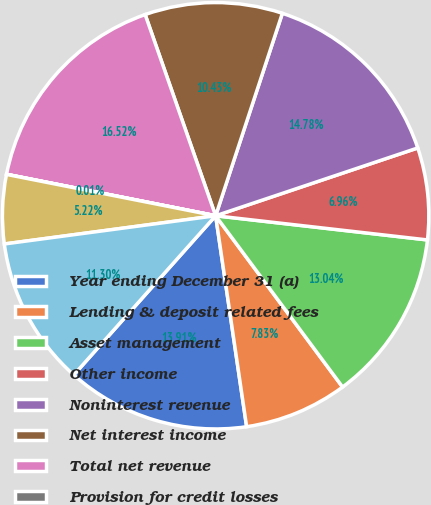Convert chart. <chart><loc_0><loc_0><loc_500><loc_500><pie_chart><fcel>Year ending December 31 (a)<fcel>Lending & deposit related fees<fcel>Asset management<fcel>Other income<fcel>Noninterest revenue<fcel>Net interest income<fcel>Total net revenue<fcel>Provision for credit losses<fcel>Credit reimbursement (to) from<fcel>Compensation expense<nl><fcel>13.91%<fcel>7.83%<fcel>13.04%<fcel>6.96%<fcel>14.78%<fcel>10.43%<fcel>16.52%<fcel>0.01%<fcel>5.22%<fcel>11.3%<nl></chart> 